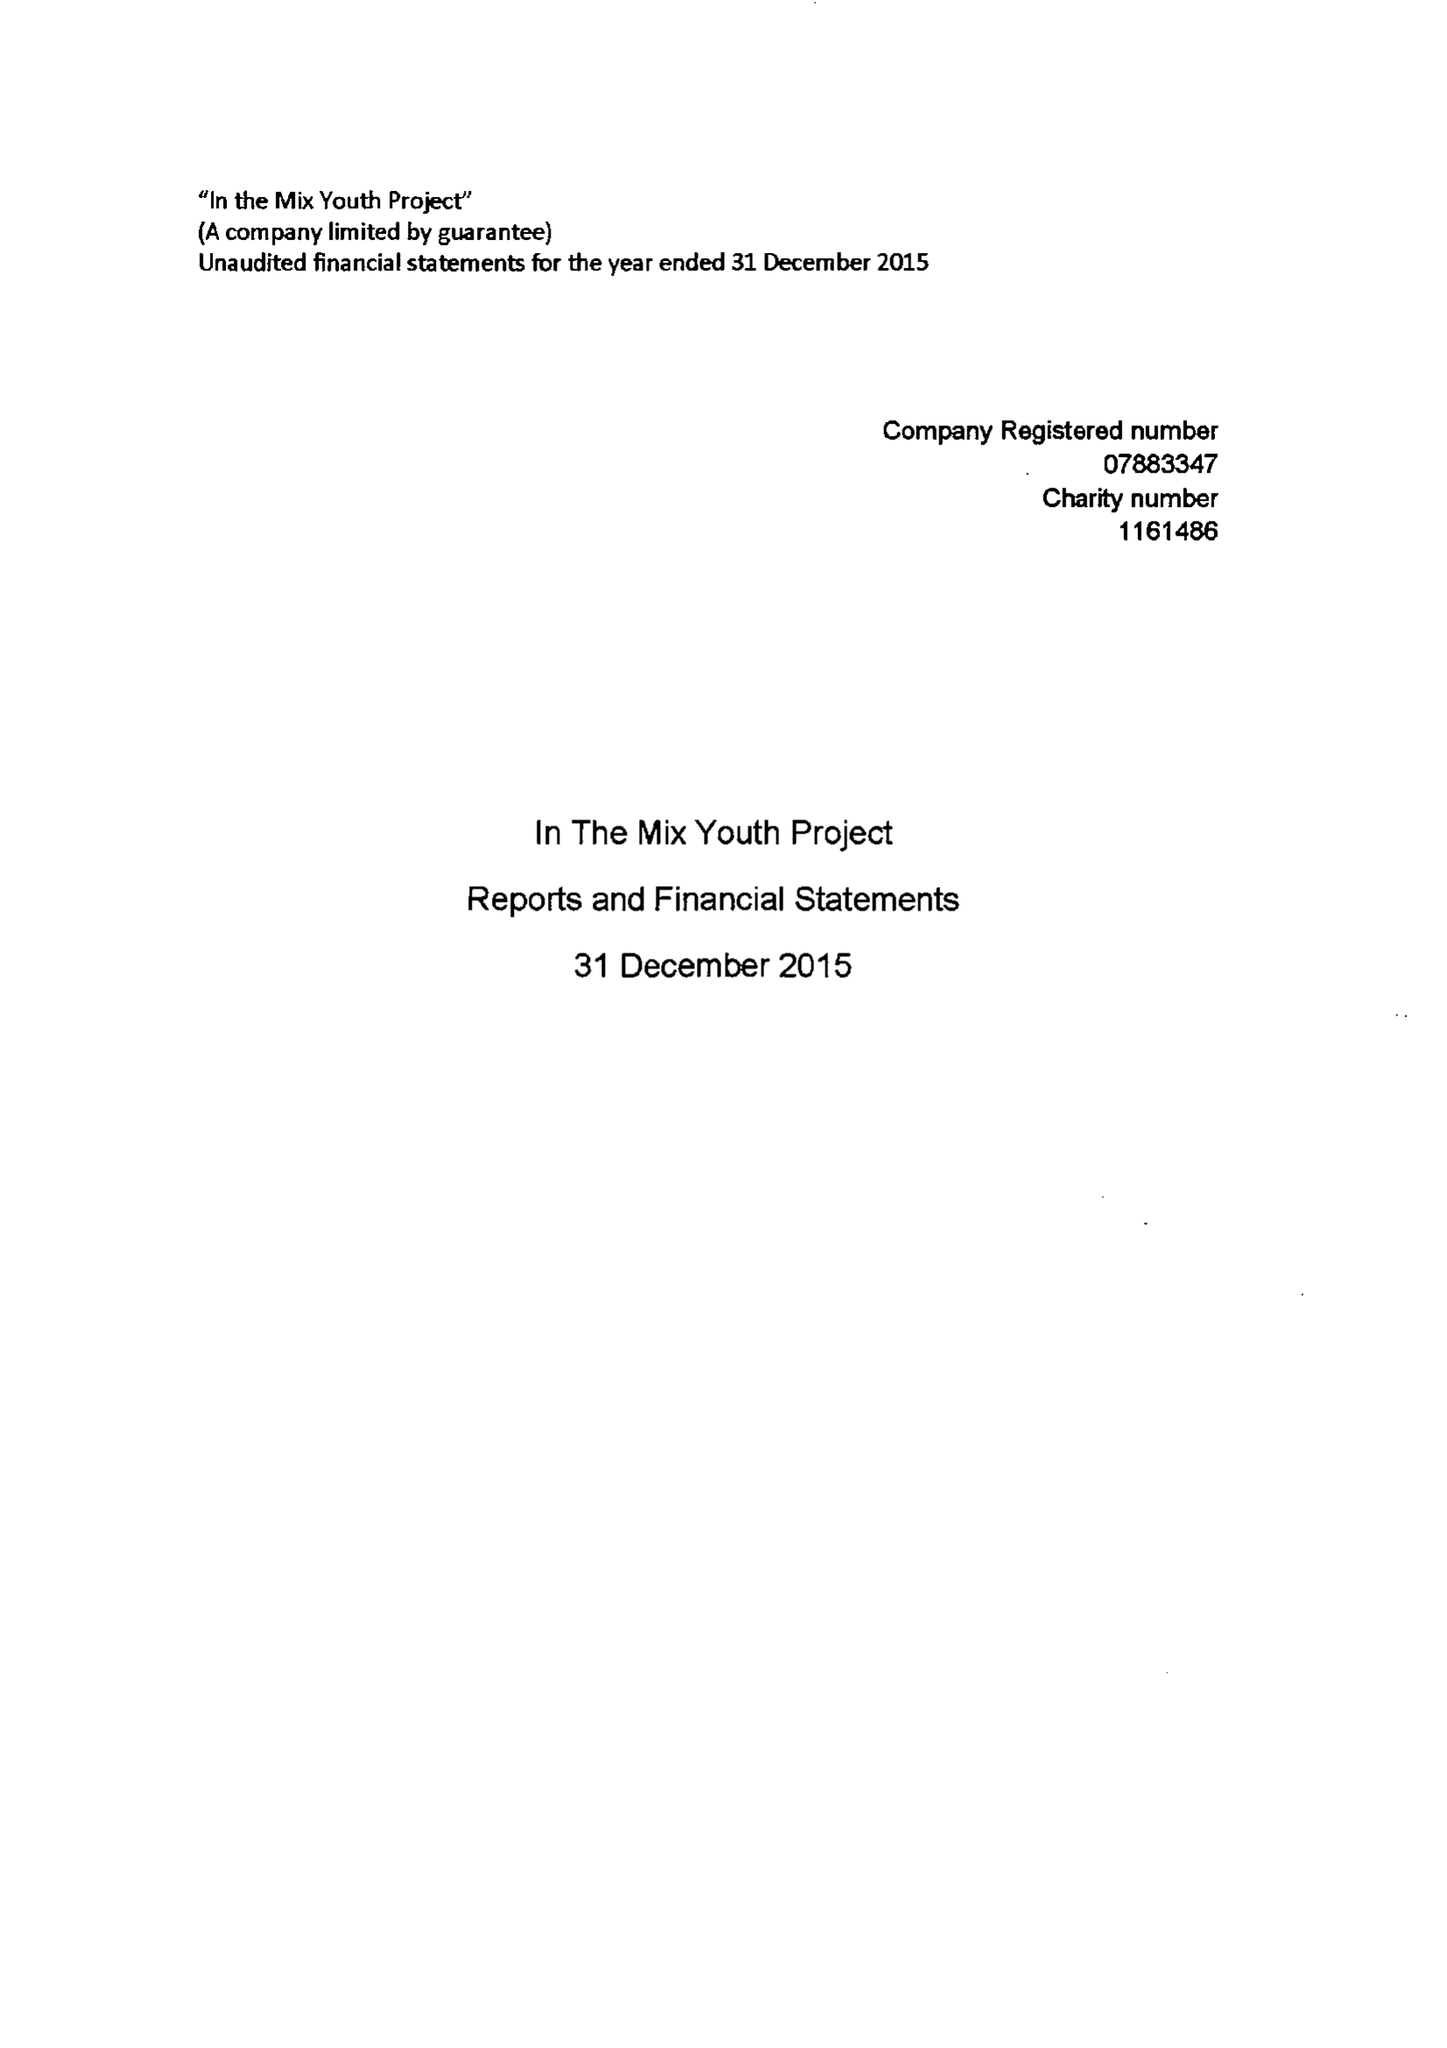What is the value for the spending_annually_in_british_pounds?
Answer the question using a single word or phrase. 26723.00 